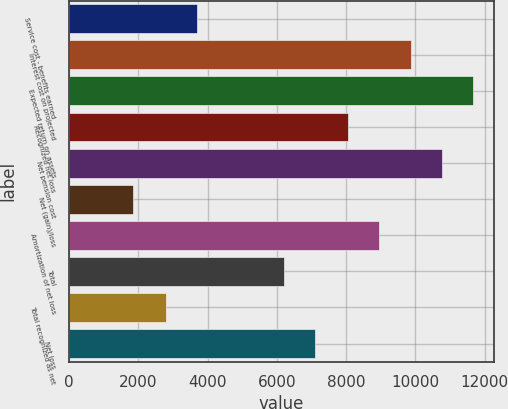Convert chart to OTSL. <chart><loc_0><loc_0><loc_500><loc_500><bar_chart><fcel>Service cost - benefits earned<fcel>Interest cost on projected<fcel>Expected return on assets<fcel>Recognized net loss<fcel>Net pension cost<fcel>Net (gain)/loss<fcel>Amortization of net loss<fcel>Total<fcel>Total recognized as net<fcel>Net loss<nl><fcel>3685.6<fcel>9862.2<fcel>11671.4<fcel>8053<fcel>10766.8<fcel>1853<fcel>8957.6<fcel>6200<fcel>2781<fcel>7104.6<nl></chart> 